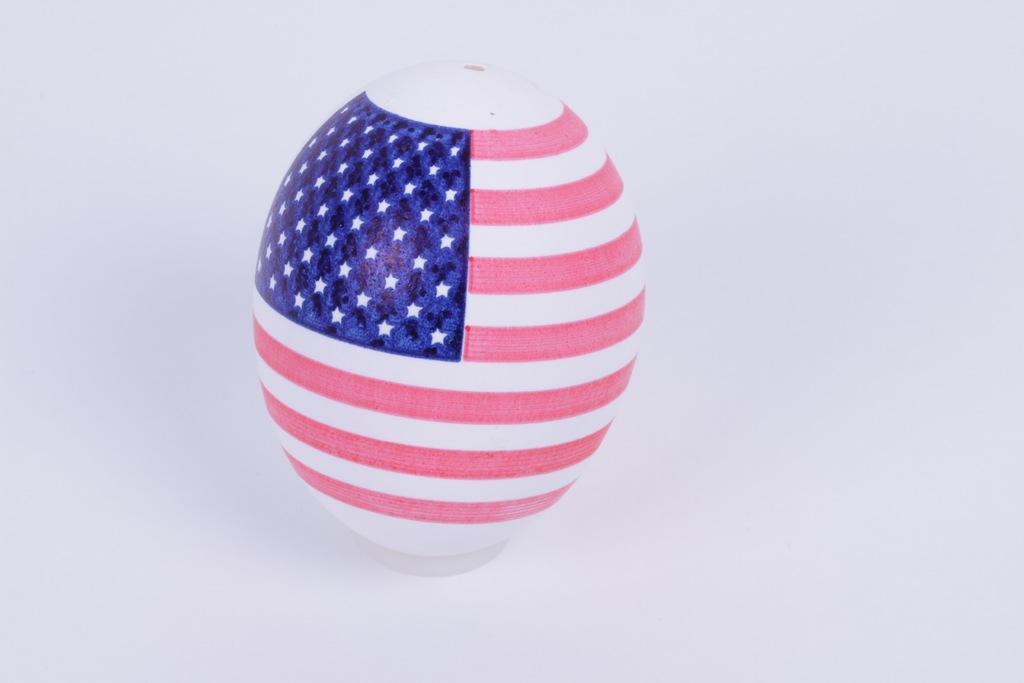How would you summarize this image in a sentence or two? In this picture we can observe an oval shaped object on which there are pink and white color stripes. We can observe blue color pant with white color stars on it. The background is in white color 